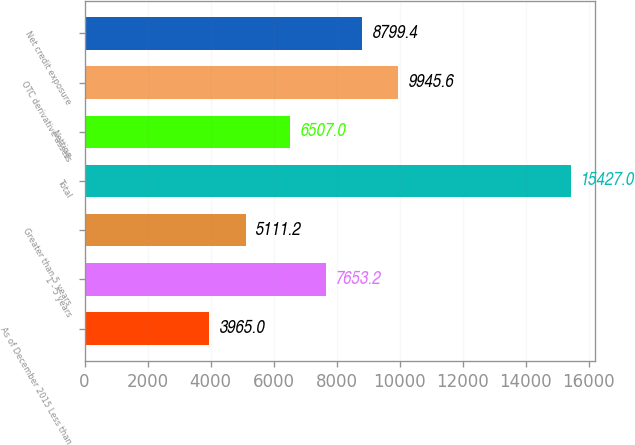Convert chart to OTSL. <chart><loc_0><loc_0><loc_500><loc_500><bar_chart><fcel>As of December 2015 Less than<fcel>1 - 5 years<fcel>Greater than 5 years<fcel>Total<fcel>Netting<fcel>OTC derivative assets<fcel>Net credit exposure<nl><fcel>3965<fcel>7653.2<fcel>5111.2<fcel>15427<fcel>6507<fcel>9945.6<fcel>8799.4<nl></chart> 